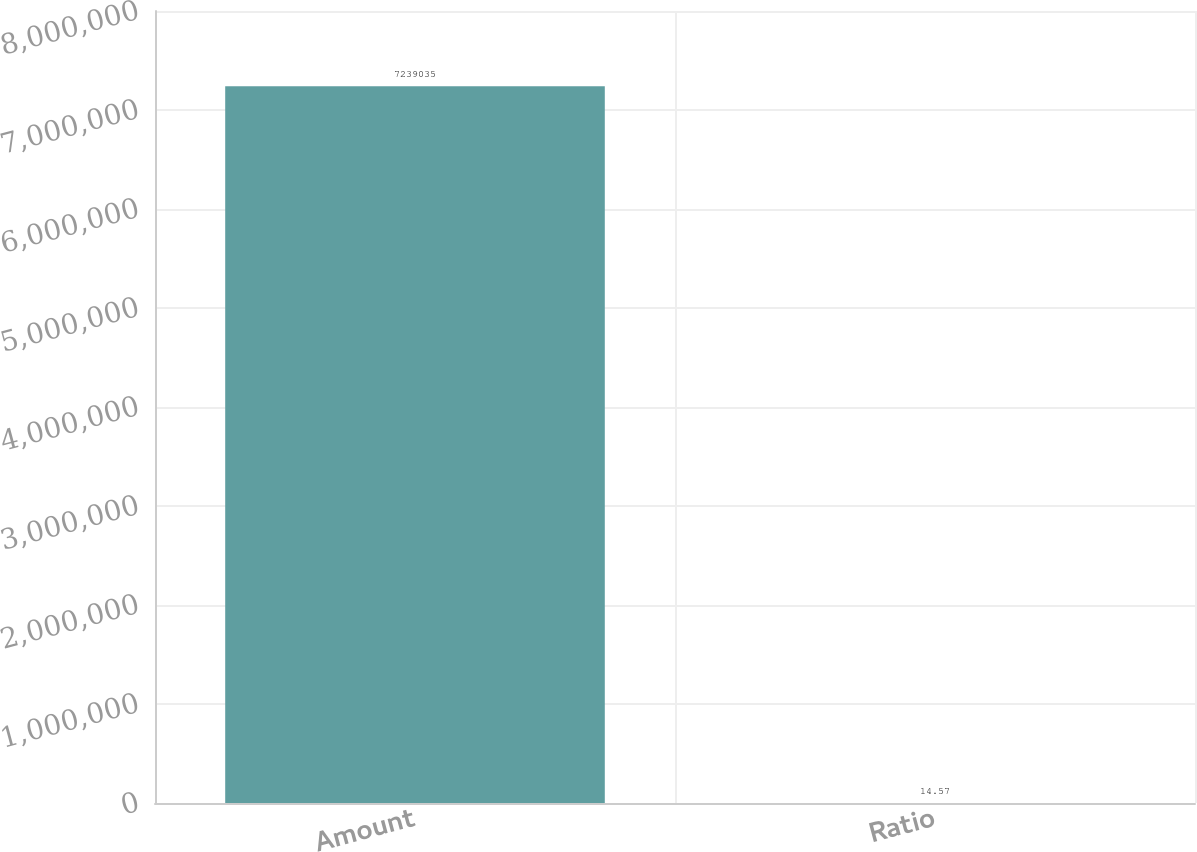<chart> <loc_0><loc_0><loc_500><loc_500><bar_chart><fcel>Amount<fcel>Ratio<nl><fcel>7.23904e+06<fcel>14.57<nl></chart> 